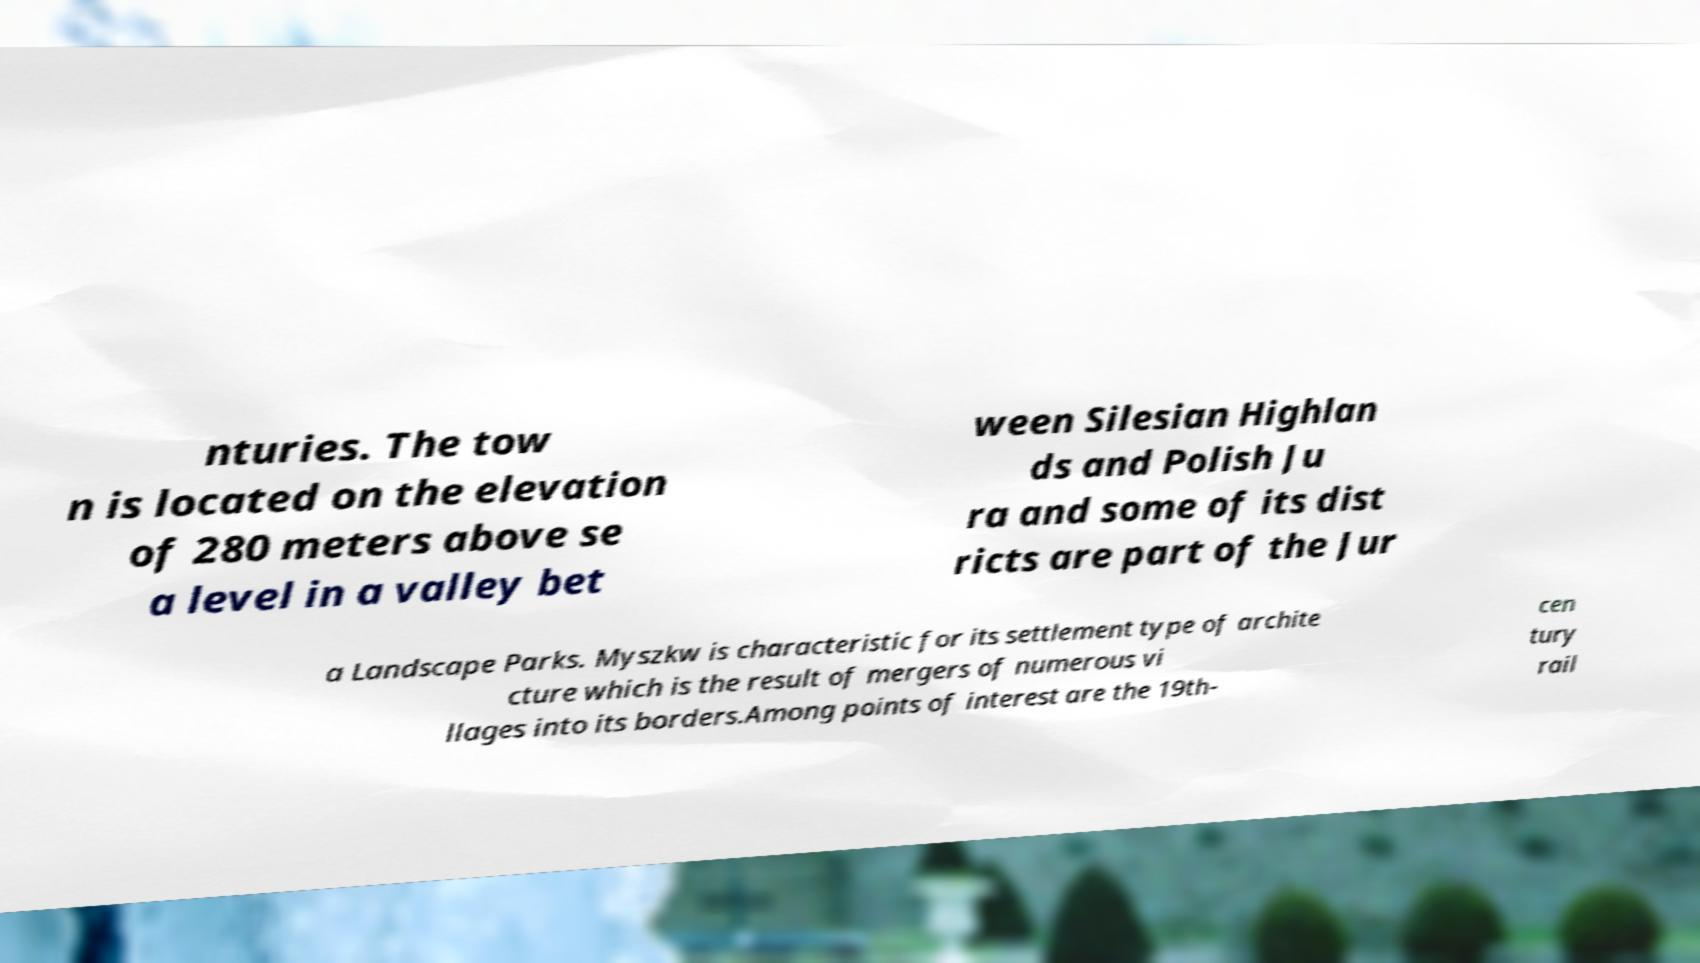Please read and relay the text visible in this image. What does it say? nturies. The tow n is located on the elevation of 280 meters above se a level in a valley bet ween Silesian Highlan ds and Polish Ju ra and some of its dist ricts are part of the Jur a Landscape Parks. Myszkw is characteristic for its settlement type of archite cture which is the result of mergers of numerous vi llages into its borders.Among points of interest are the 19th- cen tury rail 